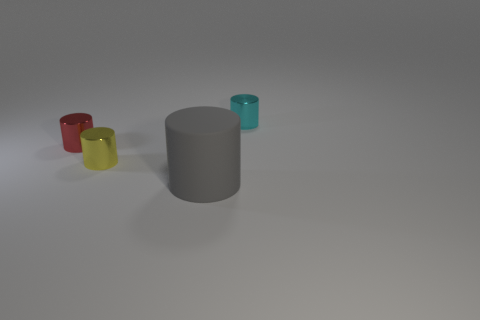Subtract all small red metal cylinders. How many cylinders are left? 3 Subtract all cyan cylinders. How many cylinders are left? 3 Subtract 1 cylinders. How many cylinders are left? 3 Subtract all blue cylinders. Subtract all cyan cubes. How many cylinders are left? 4 Add 4 rubber balls. How many objects exist? 8 Add 1 red metal objects. How many red metal objects are left? 2 Add 1 tiny gray objects. How many tiny gray objects exist? 1 Subtract 0 yellow cubes. How many objects are left? 4 Subtract all tiny purple metallic cubes. Subtract all yellow things. How many objects are left? 3 